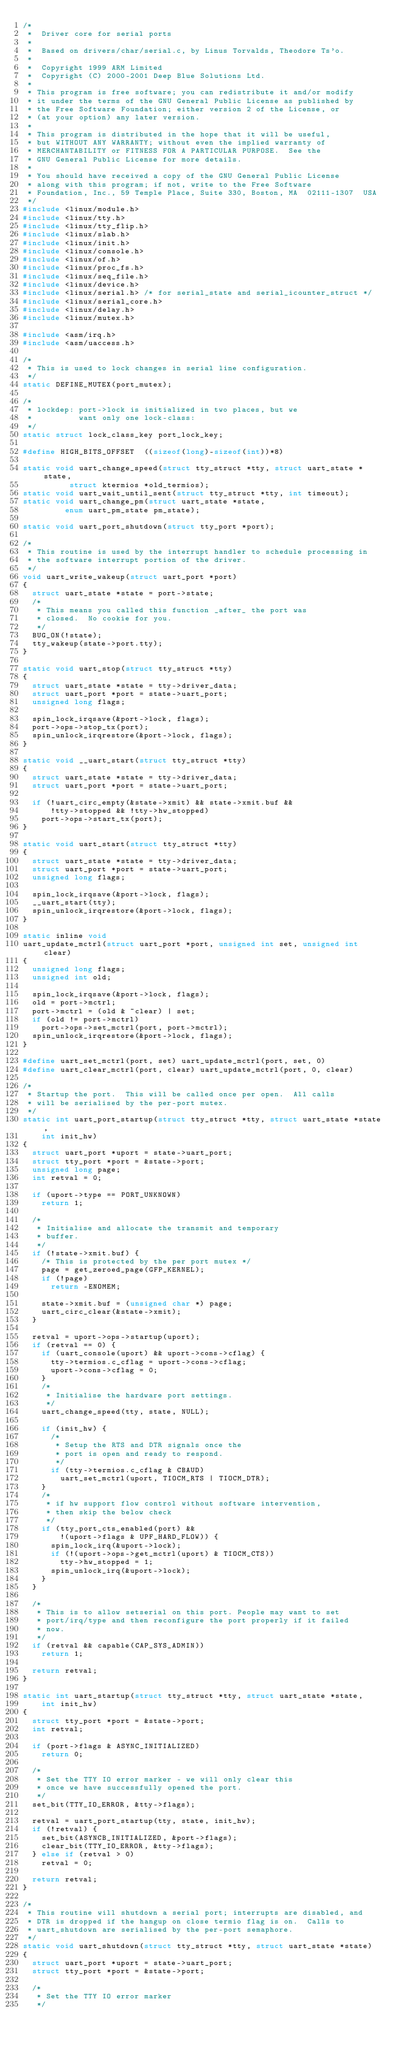<code> <loc_0><loc_0><loc_500><loc_500><_C_>/*
 *  Driver core for serial ports
 *
 *  Based on drivers/char/serial.c, by Linus Torvalds, Theodore Ts'o.
 *
 *  Copyright 1999 ARM Limited
 *  Copyright (C) 2000-2001 Deep Blue Solutions Ltd.
 *
 * This program is free software; you can redistribute it and/or modify
 * it under the terms of the GNU General Public License as published by
 * the Free Software Foundation; either version 2 of the License, or
 * (at your option) any later version.
 *
 * This program is distributed in the hope that it will be useful,
 * but WITHOUT ANY WARRANTY; without even the implied warranty of
 * MERCHANTABILITY or FITNESS FOR A PARTICULAR PURPOSE.  See the
 * GNU General Public License for more details.
 *
 * You should have received a copy of the GNU General Public License
 * along with this program; if not, write to the Free Software
 * Foundation, Inc., 59 Temple Place, Suite 330, Boston, MA  02111-1307  USA
 */
#include <linux/module.h>
#include <linux/tty.h>
#include <linux/tty_flip.h>
#include <linux/slab.h>
#include <linux/init.h>
#include <linux/console.h>
#include <linux/of.h>
#include <linux/proc_fs.h>
#include <linux/seq_file.h>
#include <linux/device.h>
#include <linux/serial.h> /* for serial_state and serial_icounter_struct */
#include <linux/serial_core.h>
#include <linux/delay.h>
#include <linux/mutex.h>

#include <asm/irq.h>
#include <asm/uaccess.h>

/*
 * This is used to lock changes in serial line configuration.
 */
static DEFINE_MUTEX(port_mutex);

/*
 * lockdep: port->lock is initialized in two places, but we
 *          want only one lock-class:
 */
static struct lock_class_key port_lock_key;

#define HIGH_BITS_OFFSET	((sizeof(long)-sizeof(int))*8)

static void uart_change_speed(struct tty_struct *tty, struct uart_state *state,
					struct ktermios *old_termios);
static void uart_wait_until_sent(struct tty_struct *tty, int timeout);
static void uart_change_pm(struct uart_state *state,
			   enum uart_pm_state pm_state);

static void uart_port_shutdown(struct tty_port *port);

/*
 * This routine is used by the interrupt handler to schedule processing in
 * the software interrupt portion of the driver.
 */
void uart_write_wakeup(struct uart_port *port)
{
	struct uart_state *state = port->state;
	/*
	 * This means you called this function _after_ the port was
	 * closed.  No cookie for you.
	 */
	BUG_ON(!state);
	tty_wakeup(state->port.tty);
}

static void uart_stop(struct tty_struct *tty)
{
	struct uart_state *state = tty->driver_data;
	struct uart_port *port = state->uart_port;
	unsigned long flags;

	spin_lock_irqsave(&port->lock, flags);
	port->ops->stop_tx(port);
	spin_unlock_irqrestore(&port->lock, flags);
}

static void __uart_start(struct tty_struct *tty)
{
	struct uart_state *state = tty->driver_data;
	struct uart_port *port = state->uart_port;

	if (!uart_circ_empty(&state->xmit) && state->xmit.buf &&
	    !tty->stopped && !tty->hw_stopped)
		port->ops->start_tx(port);
}

static void uart_start(struct tty_struct *tty)
{
	struct uart_state *state = tty->driver_data;
	struct uart_port *port = state->uart_port;
	unsigned long flags;

	spin_lock_irqsave(&port->lock, flags);
	__uart_start(tty);
	spin_unlock_irqrestore(&port->lock, flags);
}

static inline void
uart_update_mctrl(struct uart_port *port, unsigned int set, unsigned int clear)
{
	unsigned long flags;
	unsigned int old;

	spin_lock_irqsave(&port->lock, flags);
	old = port->mctrl;
	port->mctrl = (old & ~clear) | set;
	if (old != port->mctrl)
		port->ops->set_mctrl(port, port->mctrl);
	spin_unlock_irqrestore(&port->lock, flags);
}

#define uart_set_mctrl(port, set)	uart_update_mctrl(port, set, 0)
#define uart_clear_mctrl(port, clear)	uart_update_mctrl(port, 0, clear)

/*
 * Startup the port.  This will be called once per open.  All calls
 * will be serialised by the per-port mutex.
 */
static int uart_port_startup(struct tty_struct *tty, struct uart_state *state,
		int init_hw)
{
	struct uart_port *uport = state->uart_port;
	struct tty_port *port = &state->port;
	unsigned long page;
	int retval = 0;

	if (uport->type == PORT_UNKNOWN)
		return 1;

	/*
	 * Initialise and allocate the transmit and temporary
	 * buffer.
	 */
	if (!state->xmit.buf) {
		/* This is protected by the per port mutex */
		page = get_zeroed_page(GFP_KERNEL);
		if (!page)
			return -ENOMEM;

		state->xmit.buf = (unsigned char *) page;
		uart_circ_clear(&state->xmit);
	}

	retval = uport->ops->startup(uport);
	if (retval == 0) {
		if (uart_console(uport) && uport->cons->cflag) {
			tty->termios.c_cflag = uport->cons->cflag;
			uport->cons->cflag = 0;
		}
		/*
		 * Initialise the hardware port settings.
		 */
		uart_change_speed(tty, state, NULL);

		if (init_hw) {
			/*
			 * Setup the RTS and DTR signals once the
			 * port is open and ready to respond.
			 */
			if (tty->termios.c_cflag & CBAUD)
				uart_set_mctrl(uport, TIOCM_RTS | TIOCM_DTR);
		}
		/*
		 * if hw support flow control without software intervention,
		 * then skip the below check
		 */
		if (tty_port_cts_enabled(port) &&
		    !(uport->flags & UPF_HARD_FLOW)) {
			spin_lock_irq(&uport->lock);
			if (!(uport->ops->get_mctrl(uport) & TIOCM_CTS))
				tty->hw_stopped = 1;
			spin_unlock_irq(&uport->lock);
		}
	}

	/*
	 * This is to allow setserial on this port. People may want to set
	 * port/irq/type and then reconfigure the port properly if it failed
	 * now.
	 */
	if (retval && capable(CAP_SYS_ADMIN))
		return 1;

	return retval;
}

static int uart_startup(struct tty_struct *tty, struct uart_state *state,
		int init_hw)
{
	struct tty_port *port = &state->port;
	int retval;

	if (port->flags & ASYNC_INITIALIZED)
		return 0;

	/*
	 * Set the TTY IO error marker - we will only clear this
	 * once we have successfully opened the port.
	 */
	set_bit(TTY_IO_ERROR, &tty->flags);

	retval = uart_port_startup(tty, state, init_hw);
	if (!retval) {
		set_bit(ASYNCB_INITIALIZED, &port->flags);
		clear_bit(TTY_IO_ERROR, &tty->flags);
	} else if (retval > 0)
		retval = 0;

	return retval;
}

/*
 * This routine will shutdown a serial port; interrupts are disabled, and
 * DTR is dropped if the hangup on close termio flag is on.  Calls to
 * uart_shutdown are serialised by the per-port semaphore.
 */
static void uart_shutdown(struct tty_struct *tty, struct uart_state *state)
{
	struct uart_port *uport = state->uart_port;
	struct tty_port *port = &state->port;

	/*
	 * Set the TTY IO error marker
	 */</code> 